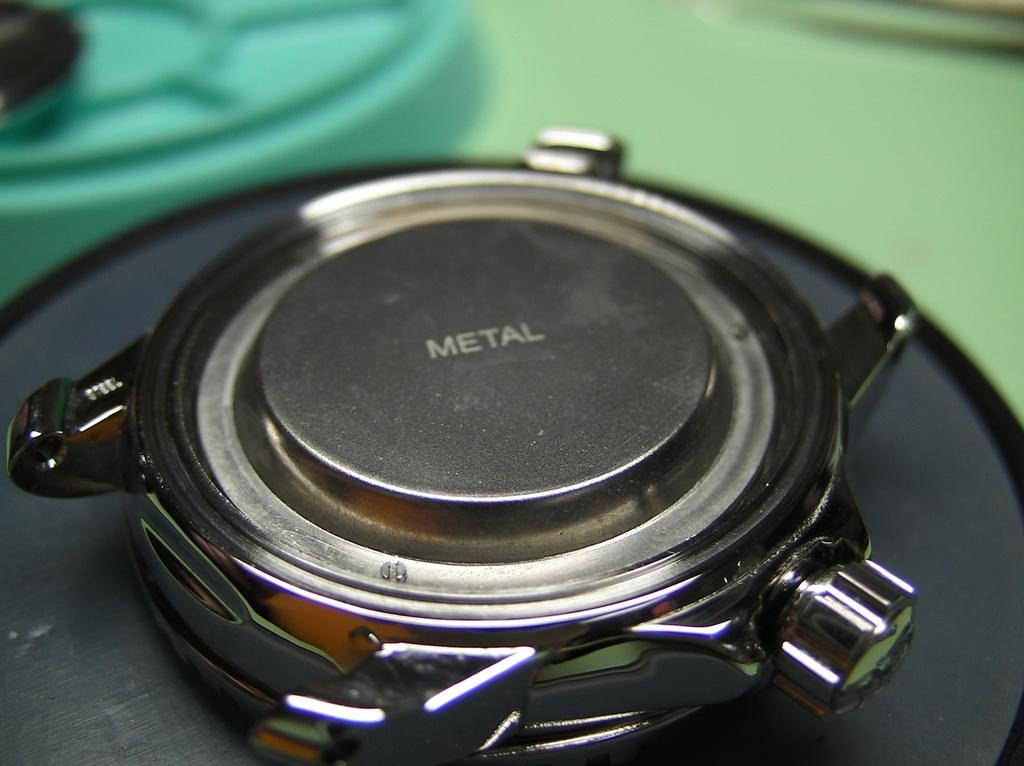Provide a one-sentence caption for the provided image. The backside of a wristwatch that says metal on it. 